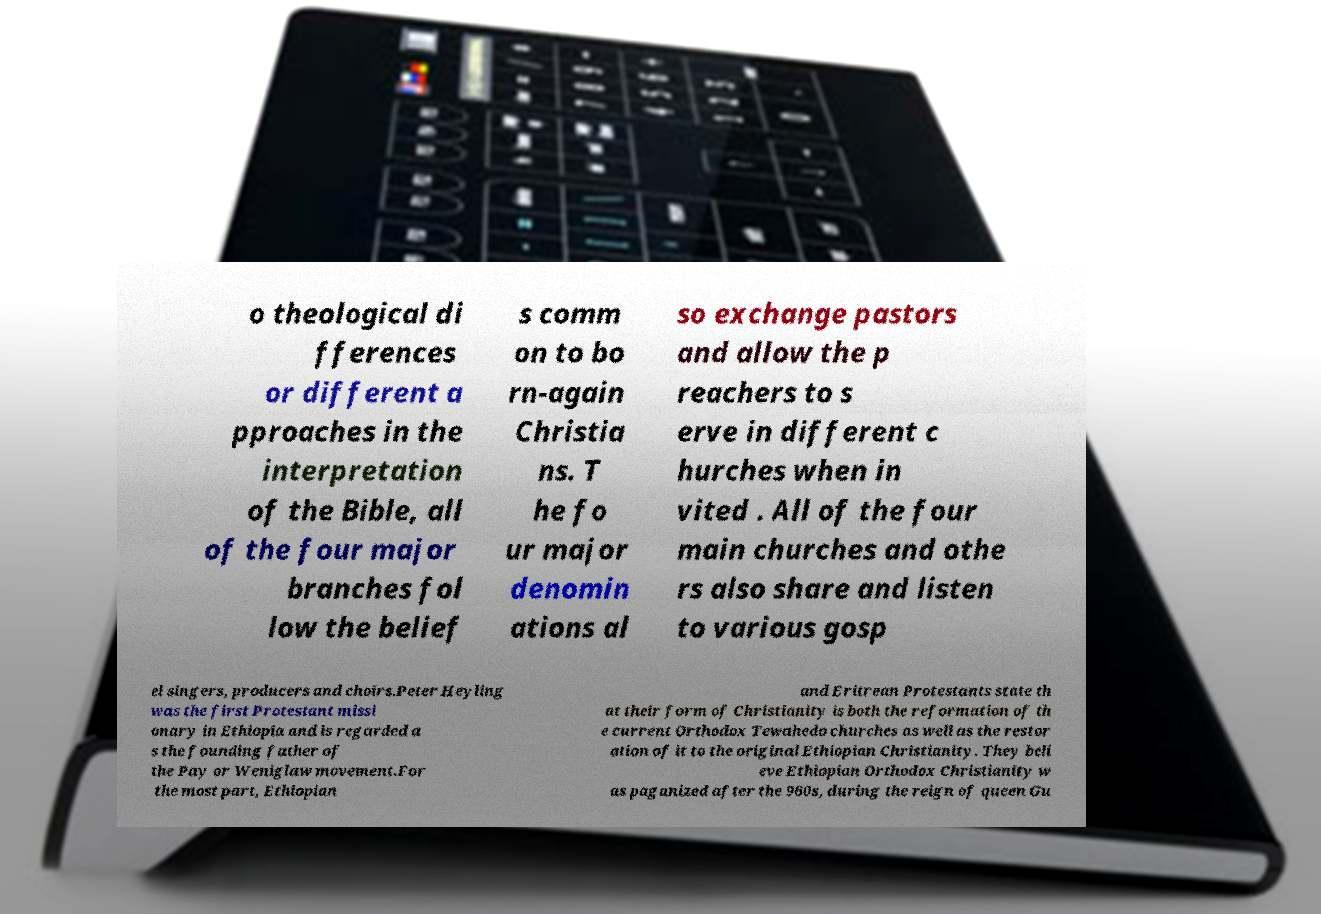Please read and relay the text visible in this image. What does it say? o theological di fferences or different a pproaches in the interpretation of the Bible, all of the four major branches fol low the belief s comm on to bo rn-again Christia ns. T he fo ur major denomin ations al so exchange pastors and allow the p reachers to s erve in different c hurches when in vited . All of the four main churches and othe rs also share and listen to various gosp el singers, producers and choirs.Peter Heyling was the first Protestant missi onary in Ethiopia and is regarded a s the founding father of the Pay or Weniglaw movement.For the most part, Ethiopian and Eritrean Protestants state th at their form of Christianity is both the reformation of th e current Orthodox Tewahedo churches as well as the restor ation of it to the original Ethiopian Christianity. They beli eve Ethiopian Orthodox Christianity w as paganized after the 960s, during the reign of queen Gu 